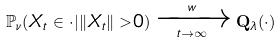Convert formula to latex. <formula><loc_0><loc_0><loc_500><loc_500>\mathbb { P } _ { \nu } ( X _ { t } \in \cdot | \| X _ { t } \| > 0 ) \xrightarrow [ t \to \infty ] { w } \mathbf Q _ { \lambda } ( \cdot )</formula> 